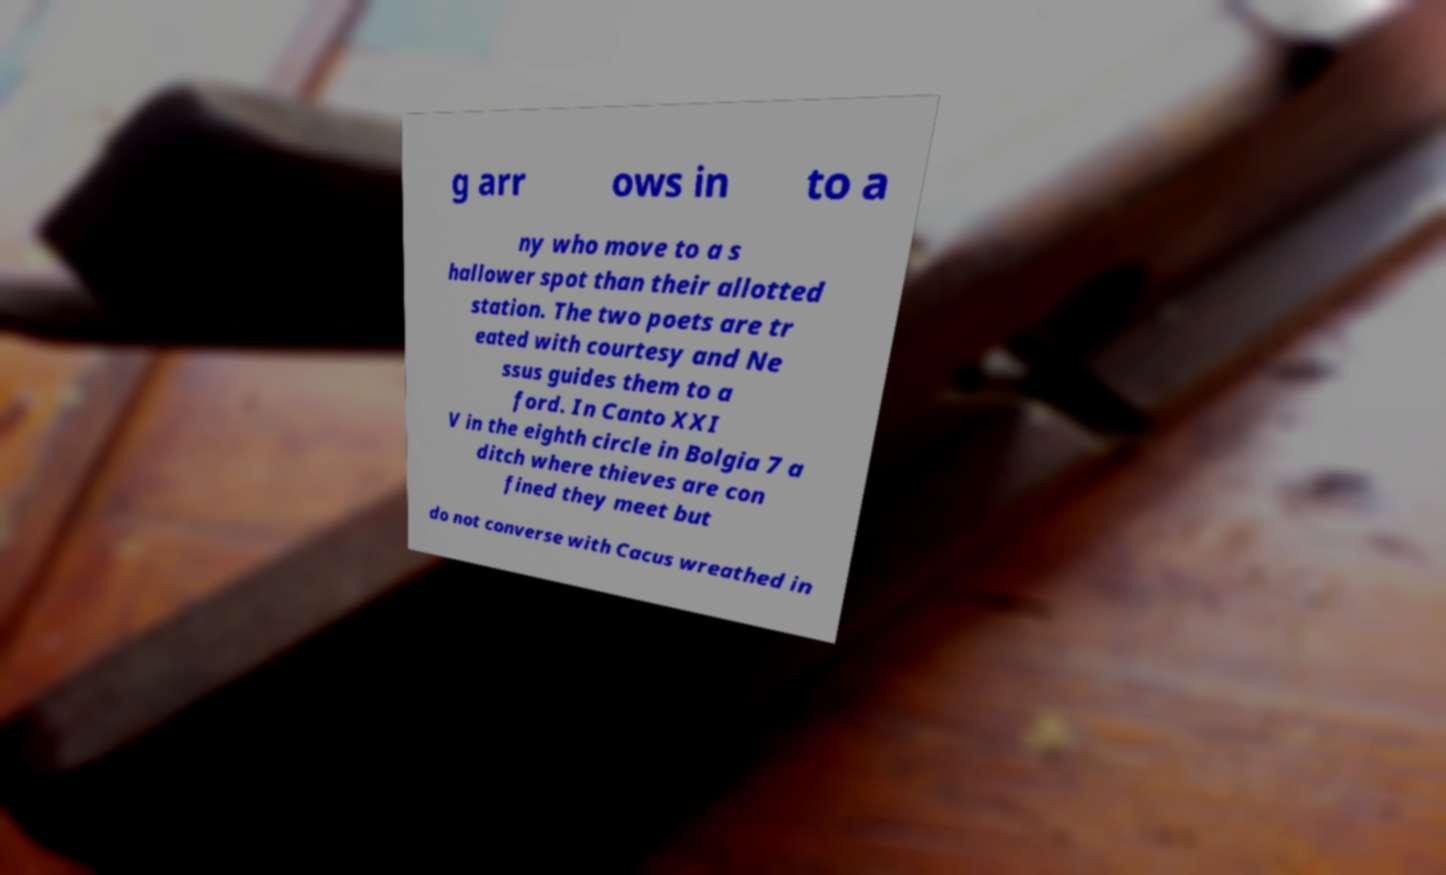Can you read and provide the text displayed in the image?This photo seems to have some interesting text. Can you extract and type it out for me? g arr ows in to a ny who move to a s hallower spot than their allotted station. The two poets are tr eated with courtesy and Ne ssus guides them to a ford. In Canto XXI V in the eighth circle in Bolgia 7 a ditch where thieves are con fined they meet but do not converse with Cacus wreathed in 